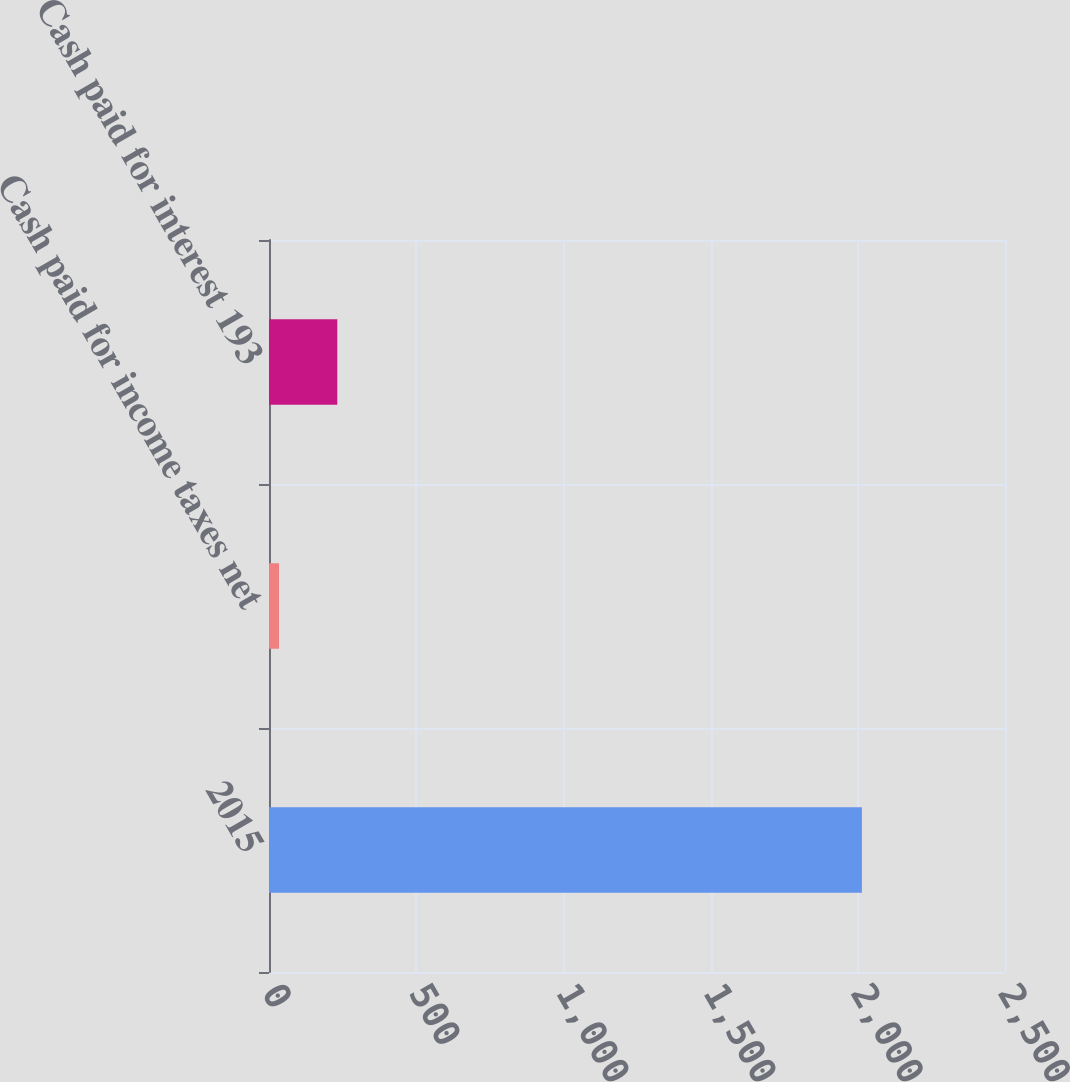Convert chart to OTSL. <chart><loc_0><loc_0><loc_500><loc_500><bar_chart><fcel>2015<fcel>Cash paid for income taxes net<fcel>Cash paid for interest 193<nl><fcel>2014<fcel>34<fcel>232<nl></chart> 